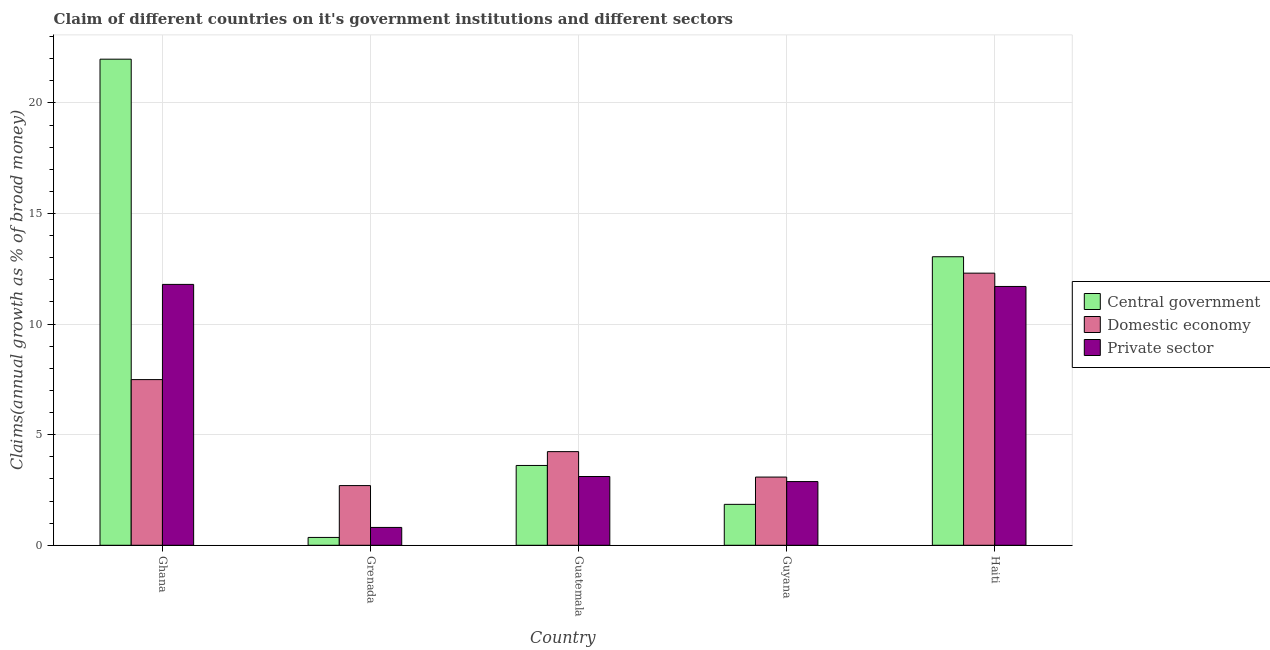How many different coloured bars are there?
Provide a succinct answer. 3. How many groups of bars are there?
Your answer should be very brief. 5. What is the label of the 4th group of bars from the left?
Your response must be concise. Guyana. What is the percentage of claim on the private sector in Grenada?
Your answer should be compact. 0.81. Across all countries, what is the maximum percentage of claim on the private sector?
Provide a succinct answer. 11.8. Across all countries, what is the minimum percentage of claim on the domestic economy?
Keep it short and to the point. 2.7. In which country was the percentage of claim on the domestic economy minimum?
Your response must be concise. Grenada. What is the total percentage of claim on the private sector in the graph?
Your answer should be compact. 30.29. What is the difference between the percentage of claim on the domestic economy in Grenada and that in Guyana?
Provide a short and direct response. -0.38. What is the difference between the percentage of claim on the private sector in Grenada and the percentage of claim on the central government in Guatemala?
Provide a succinct answer. -2.8. What is the average percentage of claim on the central government per country?
Offer a terse response. 8.17. What is the difference between the percentage of claim on the private sector and percentage of claim on the central government in Grenada?
Provide a short and direct response. 0.45. In how many countries, is the percentage of claim on the private sector greater than 6 %?
Keep it short and to the point. 2. What is the ratio of the percentage of claim on the central government in Grenada to that in Haiti?
Your answer should be very brief. 0.03. What is the difference between the highest and the second highest percentage of claim on the central government?
Provide a succinct answer. 8.93. What is the difference between the highest and the lowest percentage of claim on the domestic economy?
Make the answer very short. 9.61. In how many countries, is the percentage of claim on the private sector greater than the average percentage of claim on the private sector taken over all countries?
Provide a succinct answer. 2. What does the 3rd bar from the left in Grenada represents?
Make the answer very short. Private sector. What does the 2nd bar from the right in Guatemala represents?
Provide a succinct answer. Domestic economy. Is it the case that in every country, the sum of the percentage of claim on the central government and percentage of claim on the domestic economy is greater than the percentage of claim on the private sector?
Make the answer very short. Yes. How many countries are there in the graph?
Ensure brevity in your answer.  5. What is the difference between two consecutive major ticks on the Y-axis?
Provide a succinct answer. 5. Are the values on the major ticks of Y-axis written in scientific E-notation?
Give a very brief answer. No. Does the graph contain grids?
Provide a short and direct response. Yes. What is the title of the graph?
Your response must be concise. Claim of different countries on it's government institutions and different sectors. Does "Labor Market" appear as one of the legend labels in the graph?
Make the answer very short. No. What is the label or title of the X-axis?
Offer a very short reply. Country. What is the label or title of the Y-axis?
Ensure brevity in your answer.  Claims(annual growth as % of broad money). What is the Claims(annual growth as % of broad money) of Central government in Ghana?
Your answer should be compact. 21.98. What is the Claims(annual growth as % of broad money) in Domestic economy in Ghana?
Give a very brief answer. 7.49. What is the Claims(annual growth as % of broad money) in Private sector in Ghana?
Provide a succinct answer. 11.8. What is the Claims(annual growth as % of broad money) of Central government in Grenada?
Make the answer very short. 0.35. What is the Claims(annual growth as % of broad money) in Domestic economy in Grenada?
Offer a very short reply. 2.7. What is the Claims(annual growth as % of broad money) of Private sector in Grenada?
Offer a very short reply. 0.81. What is the Claims(annual growth as % of broad money) of Central government in Guatemala?
Keep it short and to the point. 3.61. What is the Claims(annual growth as % of broad money) of Domestic economy in Guatemala?
Your answer should be compact. 4.23. What is the Claims(annual growth as % of broad money) of Private sector in Guatemala?
Your answer should be very brief. 3.11. What is the Claims(annual growth as % of broad money) in Central government in Guyana?
Offer a terse response. 1.85. What is the Claims(annual growth as % of broad money) of Domestic economy in Guyana?
Your response must be concise. 3.08. What is the Claims(annual growth as % of broad money) of Private sector in Guyana?
Your response must be concise. 2.88. What is the Claims(annual growth as % of broad money) in Central government in Haiti?
Keep it short and to the point. 13.05. What is the Claims(annual growth as % of broad money) of Domestic economy in Haiti?
Provide a short and direct response. 12.3. What is the Claims(annual growth as % of broad money) in Private sector in Haiti?
Provide a succinct answer. 11.7. Across all countries, what is the maximum Claims(annual growth as % of broad money) of Central government?
Offer a terse response. 21.98. Across all countries, what is the maximum Claims(annual growth as % of broad money) in Domestic economy?
Make the answer very short. 12.3. Across all countries, what is the maximum Claims(annual growth as % of broad money) in Private sector?
Ensure brevity in your answer.  11.8. Across all countries, what is the minimum Claims(annual growth as % of broad money) in Central government?
Your answer should be very brief. 0.35. Across all countries, what is the minimum Claims(annual growth as % of broad money) in Domestic economy?
Your answer should be very brief. 2.7. Across all countries, what is the minimum Claims(annual growth as % of broad money) in Private sector?
Your response must be concise. 0.81. What is the total Claims(annual growth as % of broad money) in Central government in the graph?
Your answer should be very brief. 40.84. What is the total Claims(annual growth as % of broad money) of Domestic economy in the graph?
Offer a terse response. 29.81. What is the total Claims(annual growth as % of broad money) of Private sector in the graph?
Keep it short and to the point. 30.29. What is the difference between the Claims(annual growth as % of broad money) in Central government in Ghana and that in Grenada?
Offer a very short reply. 21.62. What is the difference between the Claims(annual growth as % of broad money) in Domestic economy in Ghana and that in Grenada?
Offer a very short reply. 4.79. What is the difference between the Claims(annual growth as % of broad money) in Private sector in Ghana and that in Grenada?
Your answer should be very brief. 10.99. What is the difference between the Claims(annual growth as % of broad money) in Central government in Ghana and that in Guatemala?
Keep it short and to the point. 18.37. What is the difference between the Claims(annual growth as % of broad money) of Domestic economy in Ghana and that in Guatemala?
Keep it short and to the point. 3.26. What is the difference between the Claims(annual growth as % of broad money) in Private sector in Ghana and that in Guatemala?
Give a very brief answer. 8.69. What is the difference between the Claims(annual growth as % of broad money) in Central government in Ghana and that in Guyana?
Give a very brief answer. 20.13. What is the difference between the Claims(annual growth as % of broad money) in Domestic economy in Ghana and that in Guyana?
Offer a terse response. 4.41. What is the difference between the Claims(annual growth as % of broad money) in Private sector in Ghana and that in Guyana?
Your answer should be compact. 8.91. What is the difference between the Claims(annual growth as % of broad money) of Central government in Ghana and that in Haiti?
Provide a succinct answer. 8.93. What is the difference between the Claims(annual growth as % of broad money) in Domestic economy in Ghana and that in Haiti?
Offer a very short reply. -4.81. What is the difference between the Claims(annual growth as % of broad money) in Private sector in Ghana and that in Haiti?
Make the answer very short. 0.09. What is the difference between the Claims(annual growth as % of broad money) in Central government in Grenada and that in Guatemala?
Your answer should be compact. -3.25. What is the difference between the Claims(annual growth as % of broad money) of Domestic economy in Grenada and that in Guatemala?
Your answer should be compact. -1.54. What is the difference between the Claims(annual growth as % of broad money) in Private sector in Grenada and that in Guatemala?
Your answer should be very brief. -2.3. What is the difference between the Claims(annual growth as % of broad money) in Central government in Grenada and that in Guyana?
Your answer should be very brief. -1.5. What is the difference between the Claims(annual growth as % of broad money) in Domestic economy in Grenada and that in Guyana?
Offer a terse response. -0.38. What is the difference between the Claims(annual growth as % of broad money) in Private sector in Grenada and that in Guyana?
Give a very brief answer. -2.07. What is the difference between the Claims(annual growth as % of broad money) of Central government in Grenada and that in Haiti?
Ensure brevity in your answer.  -12.69. What is the difference between the Claims(annual growth as % of broad money) in Domestic economy in Grenada and that in Haiti?
Offer a terse response. -9.61. What is the difference between the Claims(annual growth as % of broad money) in Private sector in Grenada and that in Haiti?
Ensure brevity in your answer.  -10.9. What is the difference between the Claims(annual growth as % of broad money) in Central government in Guatemala and that in Guyana?
Your answer should be compact. 1.76. What is the difference between the Claims(annual growth as % of broad money) of Domestic economy in Guatemala and that in Guyana?
Offer a terse response. 1.15. What is the difference between the Claims(annual growth as % of broad money) in Private sector in Guatemala and that in Guyana?
Make the answer very short. 0.23. What is the difference between the Claims(annual growth as % of broad money) of Central government in Guatemala and that in Haiti?
Offer a terse response. -9.44. What is the difference between the Claims(annual growth as % of broad money) in Domestic economy in Guatemala and that in Haiti?
Make the answer very short. -8.07. What is the difference between the Claims(annual growth as % of broad money) of Private sector in Guatemala and that in Haiti?
Your response must be concise. -8.59. What is the difference between the Claims(annual growth as % of broad money) in Central government in Guyana and that in Haiti?
Make the answer very short. -11.2. What is the difference between the Claims(annual growth as % of broad money) of Domestic economy in Guyana and that in Haiti?
Your answer should be very brief. -9.22. What is the difference between the Claims(annual growth as % of broad money) of Private sector in Guyana and that in Haiti?
Your response must be concise. -8.82. What is the difference between the Claims(annual growth as % of broad money) in Central government in Ghana and the Claims(annual growth as % of broad money) in Domestic economy in Grenada?
Make the answer very short. 19.28. What is the difference between the Claims(annual growth as % of broad money) in Central government in Ghana and the Claims(annual growth as % of broad money) in Private sector in Grenada?
Offer a terse response. 21.17. What is the difference between the Claims(annual growth as % of broad money) in Domestic economy in Ghana and the Claims(annual growth as % of broad money) in Private sector in Grenada?
Your answer should be compact. 6.68. What is the difference between the Claims(annual growth as % of broad money) of Central government in Ghana and the Claims(annual growth as % of broad money) of Domestic economy in Guatemala?
Your answer should be very brief. 17.74. What is the difference between the Claims(annual growth as % of broad money) in Central government in Ghana and the Claims(annual growth as % of broad money) in Private sector in Guatemala?
Ensure brevity in your answer.  18.87. What is the difference between the Claims(annual growth as % of broad money) in Domestic economy in Ghana and the Claims(annual growth as % of broad money) in Private sector in Guatemala?
Your answer should be compact. 4.38. What is the difference between the Claims(annual growth as % of broad money) of Central government in Ghana and the Claims(annual growth as % of broad money) of Domestic economy in Guyana?
Make the answer very short. 18.89. What is the difference between the Claims(annual growth as % of broad money) in Central government in Ghana and the Claims(annual growth as % of broad money) in Private sector in Guyana?
Your response must be concise. 19.1. What is the difference between the Claims(annual growth as % of broad money) in Domestic economy in Ghana and the Claims(annual growth as % of broad money) in Private sector in Guyana?
Provide a succinct answer. 4.61. What is the difference between the Claims(annual growth as % of broad money) of Central government in Ghana and the Claims(annual growth as % of broad money) of Domestic economy in Haiti?
Offer a very short reply. 9.67. What is the difference between the Claims(annual growth as % of broad money) in Central government in Ghana and the Claims(annual growth as % of broad money) in Private sector in Haiti?
Provide a short and direct response. 10.28. What is the difference between the Claims(annual growth as % of broad money) in Domestic economy in Ghana and the Claims(annual growth as % of broad money) in Private sector in Haiti?
Keep it short and to the point. -4.21. What is the difference between the Claims(annual growth as % of broad money) in Central government in Grenada and the Claims(annual growth as % of broad money) in Domestic economy in Guatemala?
Offer a terse response. -3.88. What is the difference between the Claims(annual growth as % of broad money) of Central government in Grenada and the Claims(annual growth as % of broad money) of Private sector in Guatemala?
Make the answer very short. -2.75. What is the difference between the Claims(annual growth as % of broad money) in Domestic economy in Grenada and the Claims(annual growth as % of broad money) in Private sector in Guatemala?
Offer a terse response. -0.41. What is the difference between the Claims(annual growth as % of broad money) in Central government in Grenada and the Claims(annual growth as % of broad money) in Domestic economy in Guyana?
Offer a terse response. -2.73. What is the difference between the Claims(annual growth as % of broad money) of Central government in Grenada and the Claims(annual growth as % of broad money) of Private sector in Guyana?
Your response must be concise. -2.53. What is the difference between the Claims(annual growth as % of broad money) in Domestic economy in Grenada and the Claims(annual growth as % of broad money) in Private sector in Guyana?
Keep it short and to the point. -0.18. What is the difference between the Claims(annual growth as % of broad money) in Central government in Grenada and the Claims(annual growth as % of broad money) in Domestic economy in Haiti?
Your response must be concise. -11.95. What is the difference between the Claims(annual growth as % of broad money) of Central government in Grenada and the Claims(annual growth as % of broad money) of Private sector in Haiti?
Offer a terse response. -11.35. What is the difference between the Claims(annual growth as % of broad money) of Domestic economy in Grenada and the Claims(annual growth as % of broad money) of Private sector in Haiti?
Make the answer very short. -9. What is the difference between the Claims(annual growth as % of broad money) in Central government in Guatemala and the Claims(annual growth as % of broad money) in Domestic economy in Guyana?
Ensure brevity in your answer.  0.53. What is the difference between the Claims(annual growth as % of broad money) in Central government in Guatemala and the Claims(annual growth as % of broad money) in Private sector in Guyana?
Ensure brevity in your answer.  0.73. What is the difference between the Claims(annual growth as % of broad money) in Domestic economy in Guatemala and the Claims(annual growth as % of broad money) in Private sector in Guyana?
Your answer should be compact. 1.35. What is the difference between the Claims(annual growth as % of broad money) of Central government in Guatemala and the Claims(annual growth as % of broad money) of Domestic economy in Haiti?
Provide a succinct answer. -8.7. What is the difference between the Claims(annual growth as % of broad money) in Central government in Guatemala and the Claims(annual growth as % of broad money) in Private sector in Haiti?
Your answer should be very brief. -8.09. What is the difference between the Claims(annual growth as % of broad money) in Domestic economy in Guatemala and the Claims(annual growth as % of broad money) in Private sector in Haiti?
Your answer should be compact. -7.47. What is the difference between the Claims(annual growth as % of broad money) of Central government in Guyana and the Claims(annual growth as % of broad money) of Domestic economy in Haiti?
Ensure brevity in your answer.  -10.45. What is the difference between the Claims(annual growth as % of broad money) of Central government in Guyana and the Claims(annual growth as % of broad money) of Private sector in Haiti?
Offer a terse response. -9.85. What is the difference between the Claims(annual growth as % of broad money) of Domestic economy in Guyana and the Claims(annual growth as % of broad money) of Private sector in Haiti?
Make the answer very short. -8.62. What is the average Claims(annual growth as % of broad money) of Central government per country?
Make the answer very short. 8.17. What is the average Claims(annual growth as % of broad money) in Domestic economy per country?
Offer a very short reply. 5.96. What is the average Claims(annual growth as % of broad money) of Private sector per country?
Offer a very short reply. 6.06. What is the difference between the Claims(annual growth as % of broad money) of Central government and Claims(annual growth as % of broad money) of Domestic economy in Ghana?
Provide a short and direct response. 14.49. What is the difference between the Claims(annual growth as % of broad money) of Central government and Claims(annual growth as % of broad money) of Private sector in Ghana?
Offer a very short reply. 10.18. What is the difference between the Claims(annual growth as % of broad money) of Domestic economy and Claims(annual growth as % of broad money) of Private sector in Ghana?
Make the answer very short. -4.3. What is the difference between the Claims(annual growth as % of broad money) of Central government and Claims(annual growth as % of broad money) of Domestic economy in Grenada?
Make the answer very short. -2.34. What is the difference between the Claims(annual growth as % of broad money) in Central government and Claims(annual growth as % of broad money) in Private sector in Grenada?
Offer a very short reply. -0.45. What is the difference between the Claims(annual growth as % of broad money) in Domestic economy and Claims(annual growth as % of broad money) in Private sector in Grenada?
Ensure brevity in your answer.  1.89. What is the difference between the Claims(annual growth as % of broad money) of Central government and Claims(annual growth as % of broad money) of Domestic economy in Guatemala?
Provide a succinct answer. -0.63. What is the difference between the Claims(annual growth as % of broad money) of Central government and Claims(annual growth as % of broad money) of Private sector in Guatemala?
Give a very brief answer. 0.5. What is the difference between the Claims(annual growth as % of broad money) of Domestic economy and Claims(annual growth as % of broad money) of Private sector in Guatemala?
Provide a succinct answer. 1.12. What is the difference between the Claims(annual growth as % of broad money) of Central government and Claims(annual growth as % of broad money) of Domestic economy in Guyana?
Offer a terse response. -1.23. What is the difference between the Claims(annual growth as % of broad money) in Central government and Claims(annual growth as % of broad money) in Private sector in Guyana?
Your response must be concise. -1.03. What is the difference between the Claims(annual growth as % of broad money) in Domestic economy and Claims(annual growth as % of broad money) in Private sector in Guyana?
Keep it short and to the point. 0.2. What is the difference between the Claims(annual growth as % of broad money) of Central government and Claims(annual growth as % of broad money) of Domestic economy in Haiti?
Offer a terse response. 0.74. What is the difference between the Claims(annual growth as % of broad money) in Central government and Claims(annual growth as % of broad money) in Private sector in Haiti?
Provide a succinct answer. 1.34. What is the difference between the Claims(annual growth as % of broad money) in Domestic economy and Claims(annual growth as % of broad money) in Private sector in Haiti?
Keep it short and to the point. 0.6. What is the ratio of the Claims(annual growth as % of broad money) of Central government in Ghana to that in Grenada?
Provide a short and direct response. 62. What is the ratio of the Claims(annual growth as % of broad money) of Domestic economy in Ghana to that in Grenada?
Offer a very short reply. 2.78. What is the ratio of the Claims(annual growth as % of broad money) of Private sector in Ghana to that in Grenada?
Provide a succinct answer. 14.62. What is the ratio of the Claims(annual growth as % of broad money) in Central government in Ghana to that in Guatemala?
Give a very brief answer. 6.09. What is the ratio of the Claims(annual growth as % of broad money) of Domestic economy in Ghana to that in Guatemala?
Ensure brevity in your answer.  1.77. What is the ratio of the Claims(annual growth as % of broad money) in Private sector in Ghana to that in Guatemala?
Make the answer very short. 3.79. What is the ratio of the Claims(annual growth as % of broad money) in Central government in Ghana to that in Guyana?
Make the answer very short. 11.88. What is the ratio of the Claims(annual growth as % of broad money) in Domestic economy in Ghana to that in Guyana?
Give a very brief answer. 2.43. What is the ratio of the Claims(annual growth as % of broad money) of Private sector in Ghana to that in Guyana?
Offer a very short reply. 4.09. What is the ratio of the Claims(annual growth as % of broad money) in Central government in Ghana to that in Haiti?
Offer a terse response. 1.68. What is the ratio of the Claims(annual growth as % of broad money) of Domestic economy in Ghana to that in Haiti?
Your answer should be very brief. 0.61. What is the ratio of the Claims(annual growth as % of broad money) in Private sector in Ghana to that in Haiti?
Give a very brief answer. 1.01. What is the ratio of the Claims(annual growth as % of broad money) in Central government in Grenada to that in Guatemala?
Make the answer very short. 0.1. What is the ratio of the Claims(annual growth as % of broad money) of Domestic economy in Grenada to that in Guatemala?
Offer a terse response. 0.64. What is the ratio of the Claims(annual growth as % of broad money) in Private sector in Grenada to that in Guatemala?
Make the answer very short. 0.26. What is the ratio of the Claims(annual growth as % of broad money) of Central government in Grenada to that in Guyana?
Your answer should be compact. 0.19. What is the ratio of the Claims(annual growth as % of broad money) of Domestic economy in Grenada to that in Guyana?
Give a very brief answer. 0.88. What is the ratio of the Claims(annual growth as % of broad money) of Private sector in Grenada to that in Guyana?
Offer a very short reply. 0.28. What is the ratio of the Claims(annual growth as % of broad money) in Central government in Grenada to that in Haiti?
Ensure brevity in your answer.  0.03. What is the ratio of the Claims(annual growth as % of broad money) in Domestic economy in Grenada to that in Haiti?
Keep it short and to the point. 0.22. What is the ratio of the Claims(annual growth as % of broad money) of Private sector in Grenada to that in Haiti?
Provide a short and direct response. 0.07. What is the ratio of the Claims(annual growth as % of broad money) of Central government in Guatemala to that in Guyana?
Offer a terse response. 1.95. What is the ratio of the Claims(annual growth as % of broad money) of Domestic economy in Guatemala to that in Guyana?
Make the answer very short. 1.37. What is the ratio of the Claims(annual growth as % of broad money) of Private sector in Guatemala to that in Guyana?
Offer a very short reply. 1.08. What is the ratio of the Claims(annual growth as % of broad money) of Central government in Guatemala to that in Haiti?
Provide a short and direct response. 0.28. What is the ratio of the Claims(annual growth as % of broad money) of Domestic economy in Guatemala to that in Haiti?
Your answer should be very brief. 0.34. What is the ratio of the Claims(annual growth as % of broad money) in Private sector in Guatemala to that in Haiti?
Provide a short and direct response. 0.27. What is the ratio of the Claims(annual growth as % of broad money) of Central government in Guyana to that in Haiti?
Give a very brief answer. 0.14. What is the ratio of the Claims(annual growth as % of broad money) of Domestic economy in Guyana to that in Haiti?
Your answer should be very brief. 0.25. What is the ratio of the Claims(annual growth as % of broad money) of Private sector in Guyana to that in Haiti?
Give a very brief answer. 0.25. What is the difference between the highest and the second highest Claims(annual growth as % of broad money) in Central government?
Your answer should be very brief. 8.93. What is the difference between the highest and the second highest Claims(annual growth as % of broad money) of Domestic economy?
Keep it short and to the point. 4.81. What is the difference between the highest and the second highest Claims(annual growth as % of broad money) in Private sector?
Give a very brief answer. 0.09. What is the difference between the highest and the lowest Claims(annual growth as % of broad money) in Central government?
Your answer should be very brief. 21.62. What is the difference between the highest and the lowest Claims(annual growth as % of broad money) of Domestic economy?
Offer a terse response. 9.61. What is the difference between the highest and the lowest Claims(annual growth as % of broad money) of Private sector?
Keep it short and to the point. 10.99. 